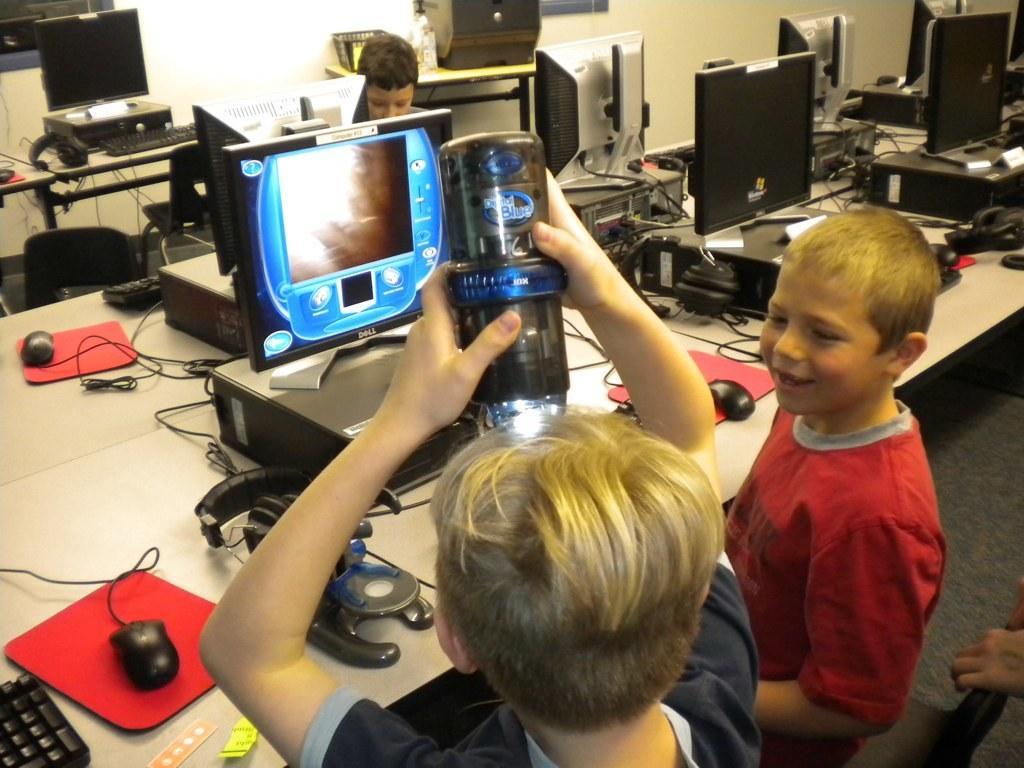How would you summarize this image in a sentence or two? In this picture we can see two boys where one is smiling and other is holding bottle with his hand and keeping on his head and in front of them on table we have monitor, mouse, keyboard, wires and in the background we can see some person sitting, wall, windows. 